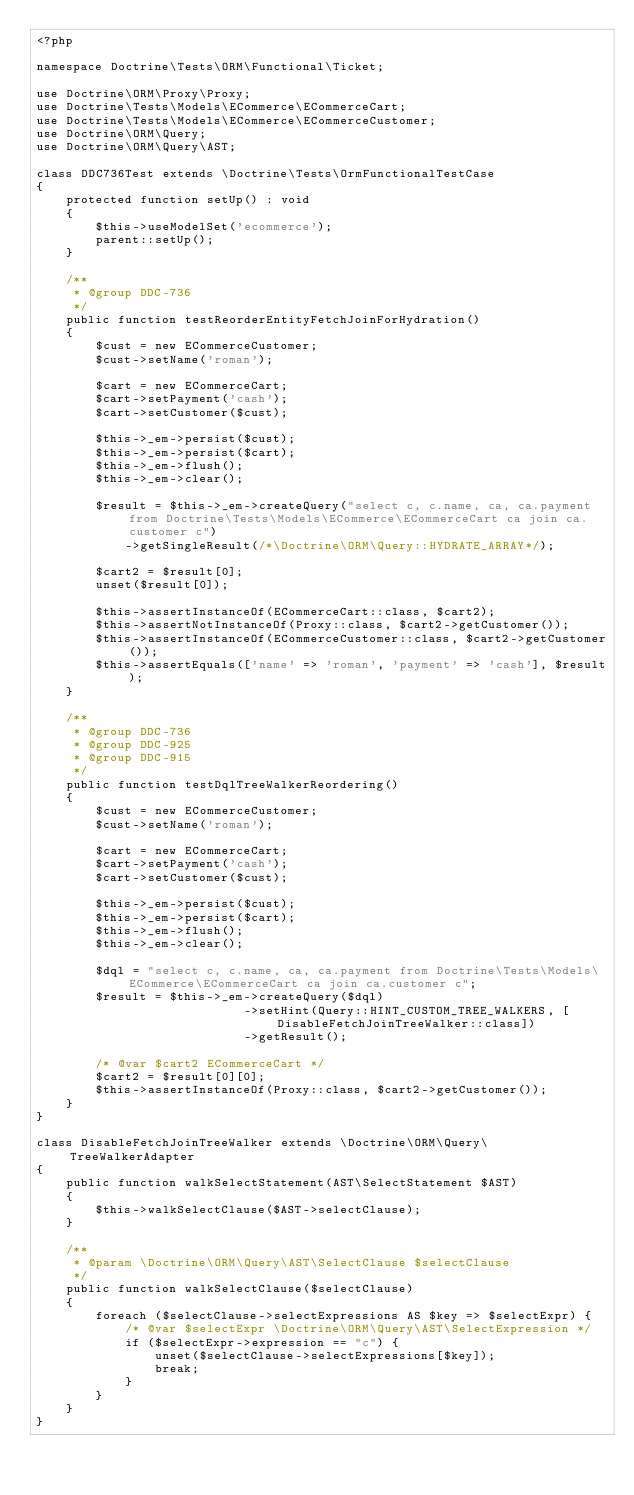Convert code to text. <code><loc_0><loc_0><loc_500><loc_500><_PHP_><?php

namespace Doctrine\Tests\ORM\Functional\Ticket;

use Doctrine\ORM\Proxy\Proxy;
use Doctrine\Tests\Models\ECommerce\ECommerceCart;
use Doctrine\Tests\Models\ECommerce\ECommerceCustomer;
use Doctrine\ORM\Query;
use Doctrine\ORM\Query\AST;

class DDC736Test extends \Doctrine\Tests\OrmFunctionalTestCase
{
    protected function setUp() : void
    {
        $this->useModelSet('ecommerce');
        parent::setUp();
    }

    /**
     * @group DDC-736
     */
    public function testReorderEntityFetchJoinForHydration()
    {
        $cust = new ECommerceCustomer;
        $cust->setName('roman');

        $cart = new ECommerceCart;
        $cart->setPayment('cash');
        $cart->setCustomer($cust);

        $this->_em->persist($cust);
        $this->_em->persist($cart);
        $this->_em->flush();
        $this->_em->clear();

        $result = $this->_em->createQuery("select c, c.name, ca, ca.payment from Doctrine\Tests\Models\ECommerce\ECommerceCart ca join ca.customer c")
            ->getSingleResult(/*\Doctrine\ORM\Query::HYDRATE_ARRAY*/);

        $cart2 = $result[0];
        unset($result[0]);

        $this->assertInstanceOf(ECommerceCart::class, $cart2);
        $this->assertNotInstanceOf(Proxy::class, $cart2->getCustomer());
        $this->assertInstanceOf(ECommerceCustomer::class, $cart2->getCustomer());
        $this->assertEquals(['name' => 'roman', 'payment' => 'cash'], $result);
    }

    /**
     * @group DDC-736
     * @group DDC-925
     * @group DDC-915
     */
    public function testDqlTreeWalkerReordering()
    {
        $cust = new ECommerceCustomer;
        $cust->setName('roman');

        $cart = new ECommerceCart;
        $cart->setPayment('cash');
        $cart->setCustomer($cust);

        $this->_em->persist($cust);
        $this->_em->persist($cart);
        $this->_em->flush();
        $this->_em->clear();

        $dql = "select c, c.name, ca, ca.payment from Doctrine\Tests\Models\ECommerce\ECommerceCart ca join ca.customer c";
        $result = $this->_em->createQuery($dql)
                            ->setHint(Query::HINT_CUSTOM_TREE_WALKERS, [DisableFetchJoinTreeWalker::class])
                            ->getResult();

        /* @var $cart2 ECommerceCart */
        $cart2 = $result[0][0];
        $this->assertInstanceOf(Proxy::class, $cart2->getCustomer());
    }
}

class DisableFetchJoinTreeWalker extends \Doctrine\ORM\Query\TreeWalkerAdapter
{
    public function walkSelectStatement(AST\SelectStatement $AST)
    {
        $this->walkSelectClause($AST->selectClause);
    }

    /**
     * @param \Doctrine\ORM\Query\AST\SelectClause $selectClause
     */
    public function walkSelectClause($selectClause)
    {
        foreach ($selectClause->selectExpressions AS $key => $selectExpr) {
            /* @var $selectExpr \Doctrine\ORM\Query\AST\SelectExpression */
            if ($selectExpr->expression == "c") {
                unset($selectClause->selectExpressions[$key]);
                break;
            }
        }
    }
}

</code> 